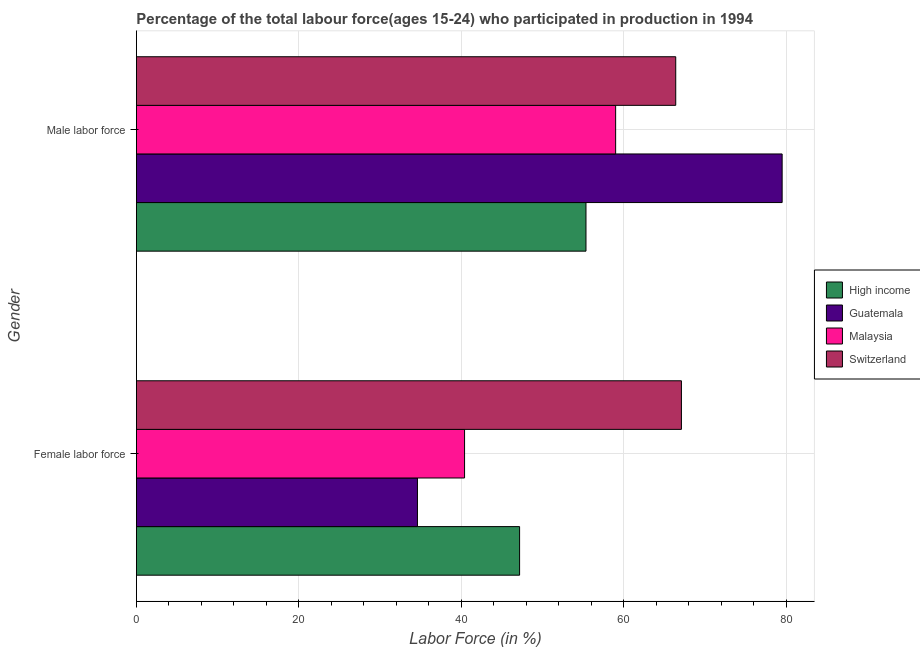How many different coloured bars are there?
Keep it short and to the point. 4. How many groups of bars are there?
Your answer should be compact. 2. What is the label of the 2nd group of bars from the top?
Ensure brevity in your answer.  Female labor force. What is the percentage of male labour force in Switzerland?
Keep it short and to the point. 66.4. Across all countries, what is the maximum percentage of female labor force?
Your answer should be very brief. 67.1. Across all countries, what is the minimum percentage of male labour force?
Offer a very short reply. 55.35. In which country was the percentage of male labour force maximum?
Your answer should be compact. Guatemala. What is the total percentage of male labour force in the graph?
Give a very brief answer. 260.25. What is the difference between the percentage of male labour force in Guatemala and that in Malaysia?
Offer a terse response. 20.5. What is the difference between the percentage of female labor force in High income and the percentage of male labour force in Switzerland?
Offer a very short reply. -19.22. What is the average percentage of male labour force per country?
Give a very brief answer. 65.06. What is the difference between the percentage of male labour force and percentage of female labor force in Switzerland?
Keep it short and to the point. -0.7. What is the ratio of the percentage of female labor force in Guatemala to that in Switzerland?
Your answer should be compact. 0.52. Is the percentage of female labor force in Switzerland less than that in Malaysia?
Ensure brevity in your answer.  No. In how many countries, is the percentage of female labor force greater than the average percentage of female labor force taken over all countries?
Your answer should be very brief. 1. What does the 4th bar from the top in Male labor force represents?
Provide a short and direct response. High income. What does the 4th bar from the bottom in Female labor force represents?
Provide a short and direct response. Switzerland. How many bars are there?
Provide a short and direct response. 8. What is the difference between two consecutive major ticks on the X-axis?
Ensure brevity in your answer.  20. Does the graph contain any zero values?
Your response must be concise. No. Does the graph contain grids?
Keep it short and to the point. Yes. How many legend labels are there?
Your response must be concise. 4. What is the title of the graph?
Make the answer very short. Percentage of the total labour force(ages 15-24) who participated in production in 1994. Does "Low income" appear as one of the legend labels in the graph?
Give a very brief answer. No. What is the label or title of the X-axis?
Offer a terse response. Labor Force (in %). What is the Labor Force (in %) of High income in Female labor force?
Give a very brief answer. 47.18. What is the Labor Force (in %) of Guatemala in Female labor force?
Offer a very short reply. 34.6. What is the Labor Force (in %) of Malaysia in Female labor force?
Keep it short and to the point. 40.4. What is the Labor Force (in %) of Switzerland in Female labor force?
Provide a succinct answer. 67.1. What is the Labor Force (in %) in High income in Male labor force?
Your answer should be very brief. 55.35. What is the Labor Force (in %) of Guatemala in Male labor force?
Ensure brevity in your answer.  79.5. What is the Labor Force (in %) in Switzerland in Male labor force?
Your response must be concise. 66.4. Across all Gender, what is the maximum Labor Force (in %) of High income?
Your response must be concise. 55.35. Across all Gender, what is the maximum Labor Force (in %) in Guatemala?
Give a very brief answer. 79.5. Across all Gender, what is the maximum Labor Force (in %) of Malaysia?
Give a very brief answer. 59. Across all Gender, what is the maximum Labor Force (in %) of Switzerland?
Provide a short and direct response. 67.1. Across all Gender, what is the minimum Labor Force (in %) of High income?
Your answer should be very brief. 47.18. Across all Gender, what is the minimum Labor Force (in %) in Guatemala?
Provide a short and direct response. 34.6. Across all Gender, what is the minimum Labor Force (in %) in Malaysia?
Provide a succinct answer. 40.4. Across all Gender, what is the minimum Labor Force (in %) of Switzerland?
Your answer should be very brief. 66.4. What is the total Labor Force (in %) in High income in the graph?
Make the answer very short. 102.53. What is the total Labor Force (in %) of Guatemala in the graph?
Offer a terse response. 114.1. What is the total Labor Force (in %) of Malaysia in the graph?
Ensure brevity in your answer.  99.4. What is the total Labor Force (in %) in Switzerland in the graph?
Provide a succinct answer. 133.5. What is the difference between the Labor Force (in %) of High income in Female labor force and that in Male labor force?
Keep it short and to the point. -8.17. What is the difference between the Labor Force (in %) of Guatemala in Female labor force and that in Male labor force?
Keep it short and to the point. -44.9. What is the difference between the Labor Force (in %) in Malaysia in Female labor force and that in Male labor force?
Offer a very short reply. -18.6. What is the difference between the Labor Force (in %) in High income in Female labor force and the Labor Force (in %) in Guatemala in Male labor force?
Offer a very short reply. -32.32. What is the difference between the Labor Force (in %) in High income in Female labor force and the Labor Force (in %) in Malaysia in Male labor force?
Your response must be concise. -11.82. What is the difference between the Labor Force (in %) of High income in Female labor force and the Labor Force (in %) of Switzerland in Male labor force?
Keep it short and to the point. -19.22. What is the difference between the Labor Force (in %) of Guatemala in Female labor force and the Labor Force (in %) of Malaysia in Male labor force?
Give a very brief answer. -24.4. What is the difference between the Labor Force (in %) in Guatemala in Female labor force and the Labor Force (in %) in Switzerland in Male labor force?
Provide a succinct answer. -31.8. What is the average Labor Force (in %) in High income per Gender?
Provide a short and direct response. 51.26. What is the average Labor Force (in %) in Guatemala per Gender?
Your answer should be compact. 57.05. What is the average Labor Force (in %) of Malaysia per Gender?
Keep it short and to the point. 49.7. What is the average Labor Force (in %) of Switzerland per Gender?
Your answer should be compact. 66.75. What is the difference between the Labor Force (in %) in High income and Labor Force (in %) in Guatemala in Female labor force?
Provide a short and direct response. 12.58. What is the difference between the Labor Force (in %) of High income and Labor Force (in %) of Malaysia in Female labor force?
Give a very brief answer. 6.78. What is the difference between the Labor Force (in %) of High income and Labor Force (in %) of Switzerland in Female labor force?
Keep it short and to the point. -19.92. What is the difference between the Labor Force (in %) in Guatemala and Labor Force (in %) in Malaysia in Female labor force?
Provide a succinct answer. -5.8. What is the difference between the Labor Force (in %) of Guatemala and Labor Force (in %) of Switzerland in Female labor force?
Provide a short and direct response. -32.5. What is the difference between the Labor Force (in %) of Malaysia and Labor Force (in %) of Switzerland in Female labor force?
Make the answer very short. -26.7. What is the difference between the Labor Force (in %) in High income and Labor Force (in %) in Guatemala in Male labor force?
Make the answer very short. -24.15. What is the difference between the Labor Force (in %) in High income and Labor Force (in %) in Malaysia in Male labor force?
Ensure brevity in your answer.  -3.65. What is the difference between the Labor Force (in %) in High income and Labor Force (in %) in Switzerland in Male labor force?
Your answer should be very brief. -11.05. What is the difference between the Labor Force (in %) in Guatemala and Labor Force (in %) in Switzerland in Male labor force?
Provide a short and direct response. 13.1. What is the ratio of the Labor Force (in %) in High income in Female labor force to that in Male labor force?
Make the answer very short. 0.85. What is the ratio of the Labor Force (in %) in Guatemala in Female labor force to that in Male labor force?
Your answer should be very brief. 0.44. What is the ratio of the Labor Force (in %) of Malaysia in Female labor force to that in Male labor force?
Give a very brief answer. 0.68. What is the ratio of the Labor Force (in %) in Switzerland in Female labor force to that in Male labor force?
Your response must be concise. 1.01. What is the difference between the highest and the second highest Labor Force (in %) in High income?
Keep it short and to the point. 8.17. What is the difference between the highest and the second highest Labor Force (in %) of Guatemala?
Make the answer very short. 44.9. What is the difference between the highest and the lowest Labor Force (in %) in High income?
Your response must be concise. 8.17. What is the difference between the highest and the lowest Labor Force (in %) of Guatemala?
Provide a succinct answer. 44.9. What is the difference between the highest and the lowest Labor Force (in %) in Malaysia?
Offer a terse response. 18.6. What is the difference between the highest and the lowest Labor Force (in %) of Switzerland?
Ensure brevity in your answer.  0.7. 